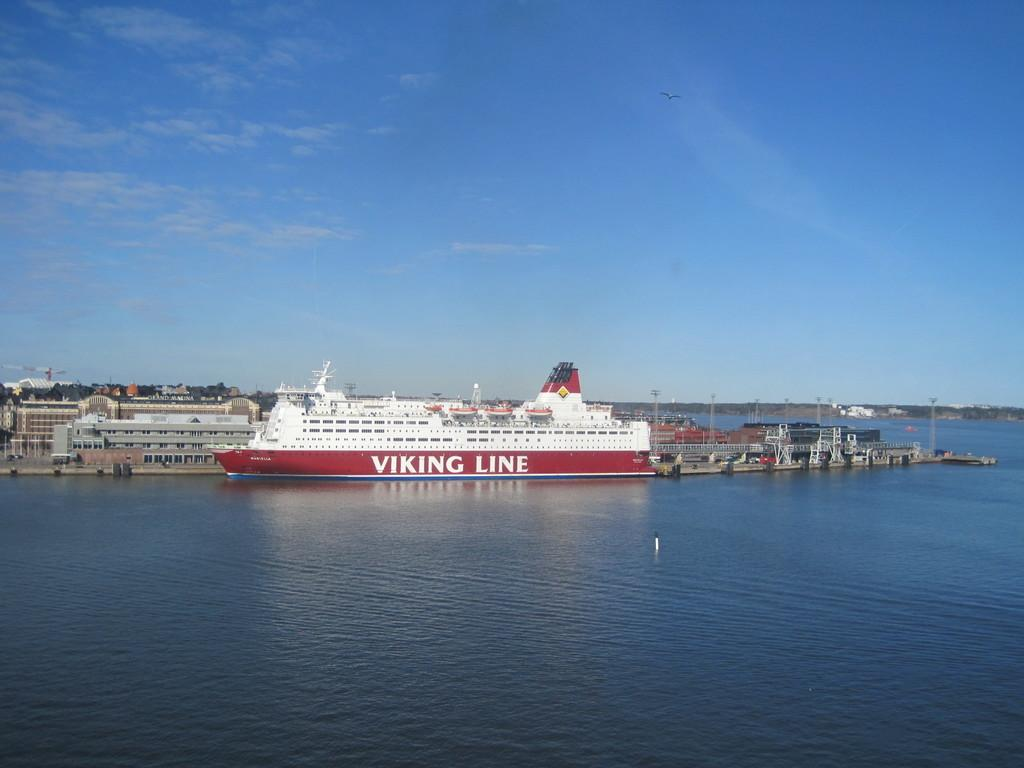What is the main subject of the image? The main subject of the image is ships on the water. What can be seen in the background of the image? In the background of the image, there are trees, buildings, and poles. What is visible in the sky at the top of the image? Clouds are visible in the sky at the top of the image. What type of boundary can be seen surrounding the scene in the image? There is no boundary visible in the image; it shows ships on the water, trees, buildings, poles, and clouds in the sky. 